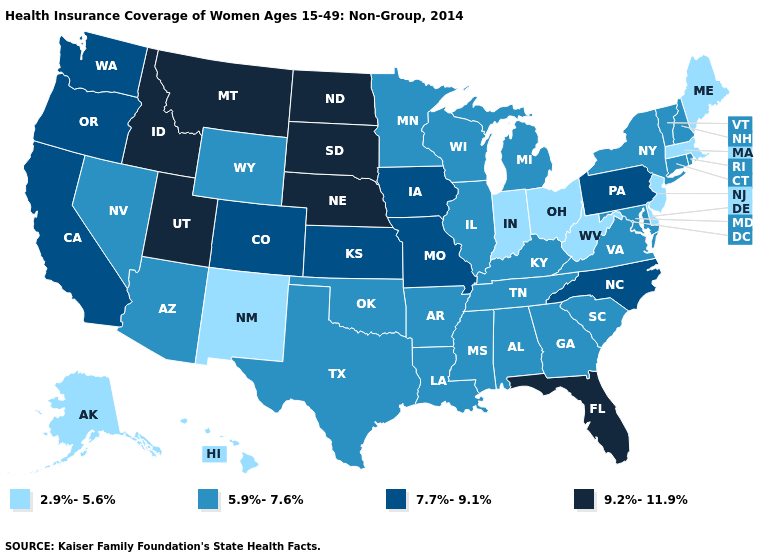Name the states that have a value in the range 7.7%-9.1%?
Be succinct. California, Colorado, Iowa, Kansas, Missouri, North Carolina, Oregon, Pennsylvania, Washington. Which states hav the highest value in the South?
Short answer required. Florida. What is the value of New Mexico?
Write a very short answer. 2.9%-5.6%. What is the highest value in the MidWest ?
Concise answer only. 9.2%-11.9%. What is the value of Nebraska?
Be succinct. 9.2%-11.9%. What is the value of Washington?
Keep it brief. 7.7%-9.1%. What is the highest value in the USA?
Answer briefly. 9.2%-11.9%. Among the states that border Pennsylvania , which have the lowest value?
Short answer required. Delaware, New Jersey, Ohio, West Virginia. Name the states that have a value in the range 2.9%-5.6%?
Be succinct. Alaska, Delaware, Hawaii, Indiana, Maine, Massachusetts, New Jersey, New Mexico, Ohio, West Virginia. Does the map have missing data?
Concise answer only. No. Name the states that have a value in the range 5.9%-7.6%?
Concise answer only. Alabama, Arizona, Arkansas, Connecticut, Georgia, Illinois, Kentucky, Louisiana, Maryland, Michigan, Minnesota, Mississippi, Nevada, New Hampshire, New York, Oklahoma, Rhode Island, South Carolina, Tennessee, Texas, Vermont, Virginia, Wisconsin, Wyoming. Name the states that have a value in the range 2.9%-5.6%?
Be succinct. Alaska, Delaware, Hawaii, Indiana, Maine, Massachusetts, New Jersey, New Mexico, Ohio, West Virginia. What is the value of Alaska?
Keep it brief. 2.9%-5.6%. What is the highest value in the USA?
Concise answer only. 9.2%-11.9%. What is the value of New York?
Keep it brief. 5.9%-7.6%. 